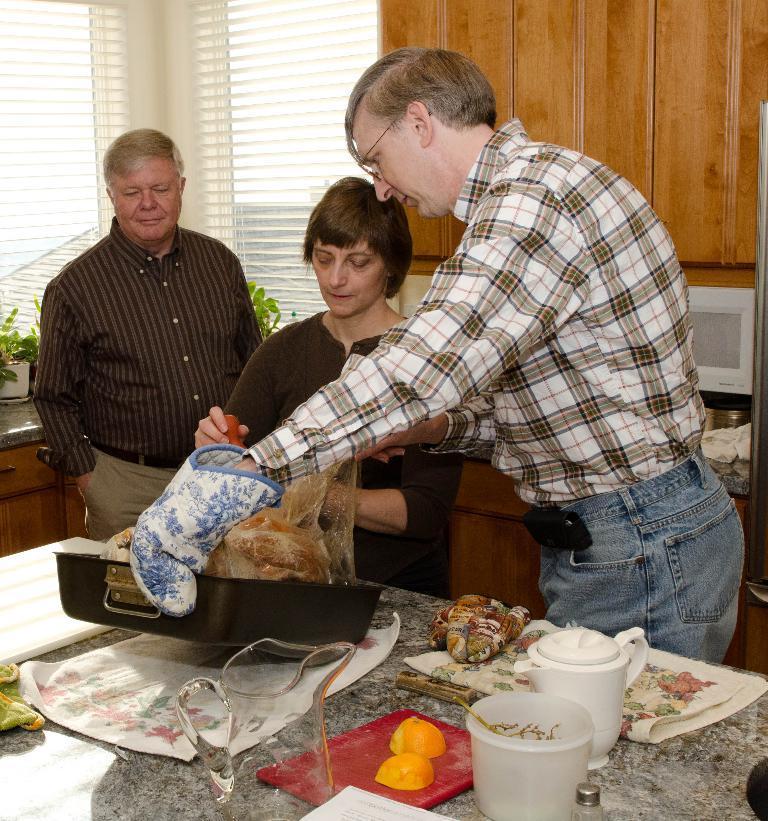Please provide a concise description of this image. On the right side a man is standing, he wore a shirt, trouser. In the middle a woman is there. On the left side there is another man looking at these things, there is a glass jug on this table. 